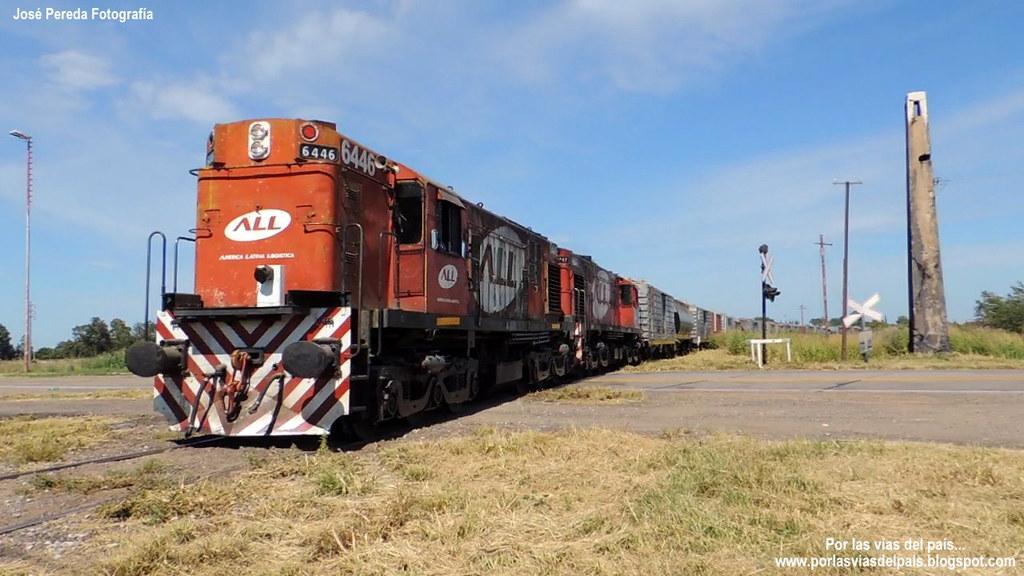Describe this image in one or two sentences. in this image there is a train in left of this image which is in red color, there is a grass at bottom of this image , there are some poles at right side of this image and there is one pole at left side of this image. there is a sky at top of this image. there is a tree at right side of this image. There is a pole at right side of this image there is a watermark at top left side of this image and bottom right corner of this image. 